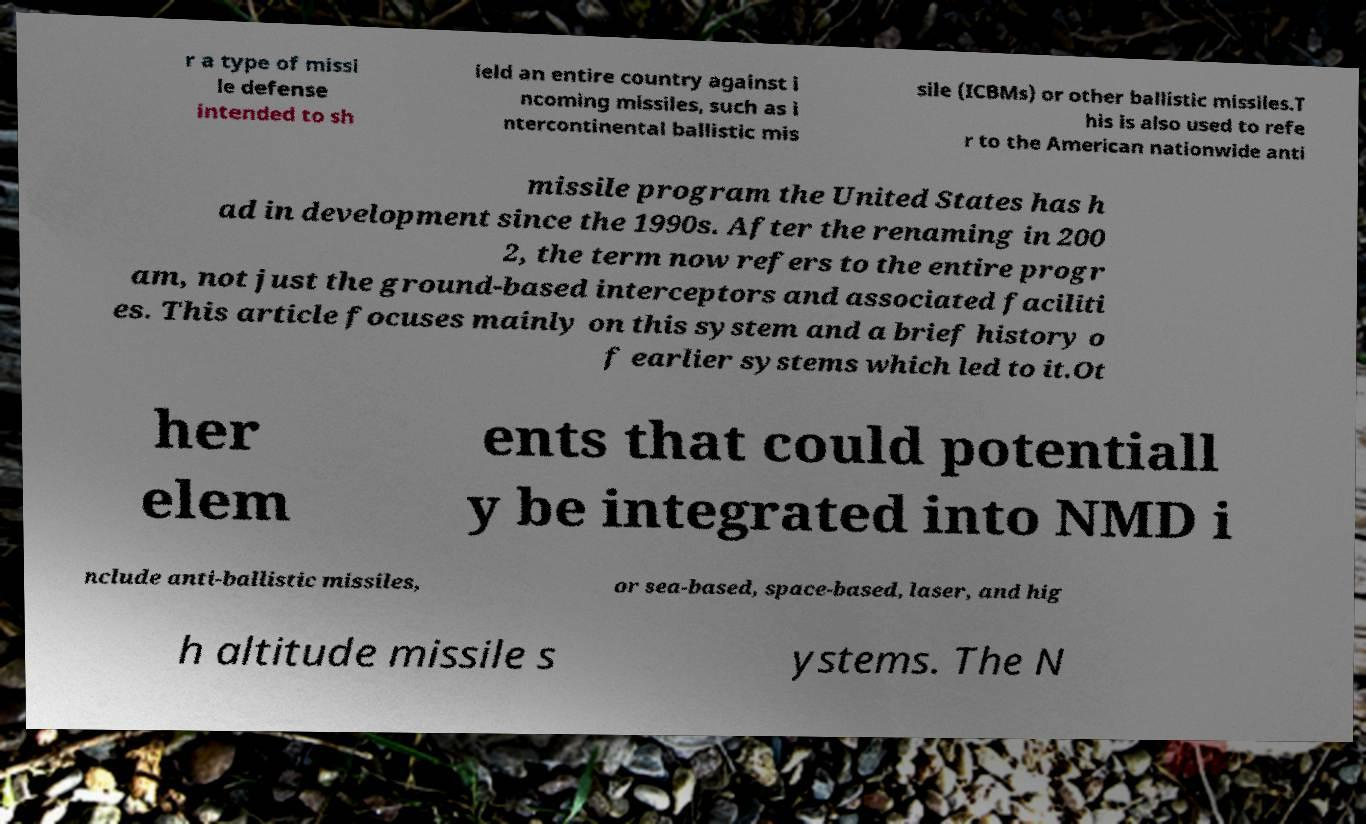Could you extract and type out the text from this image? r a type of missi le defense intended to sh ield an entire country against i ncoming missiles, such as i ntercontinental ballistic mis sile (ICBMs) or other ballistic missiles.T his is also used to refe r to the American nationwide anti missile program the United States has h ad in development since the 1990s. After the renaming in 200 2, the term now refers to the entire progr am, not just the ground-based interceptors and associated faciliti es. This article focuses mainly on this system and a brief history o f earlier systems which led to it.Ot her elem ents that could potentiall y be integrated into NMD i nclude anti-ballistic missiles, or sea-based, space-based, laser, and hig h altitude missile s ystems. The N 